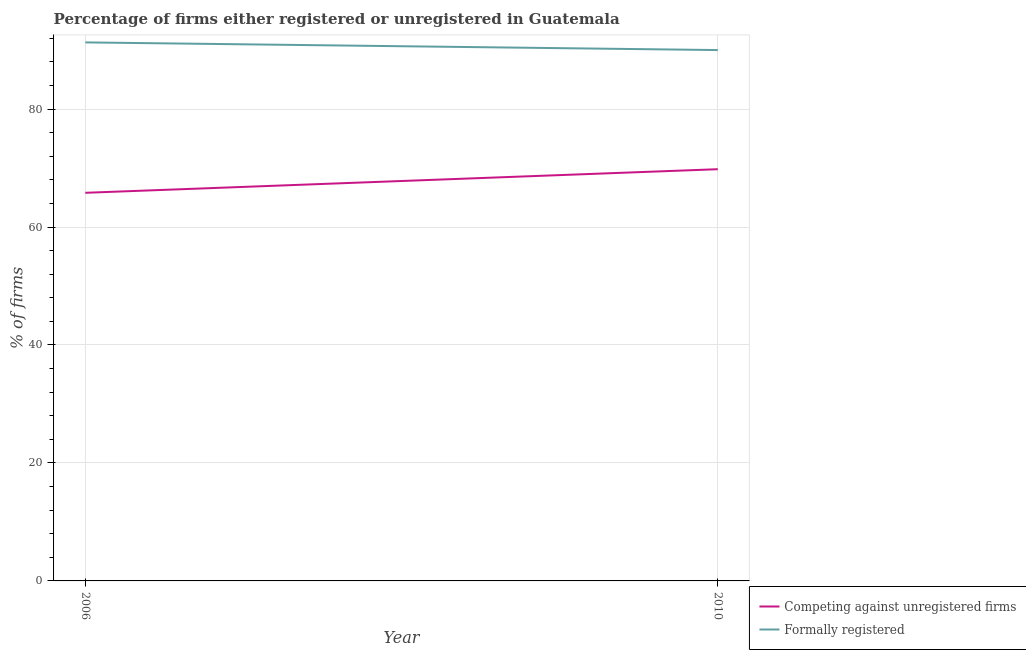How many different coloured lines are there?
Your response must be concise. 2. Is the number of lines equal to the number of legend labels?
Your answer should be very brief. Yes. Across all years, what is the maximum percentage of formally registered firms?
Make the answer very short. 91.3. Across all years, what is the minimum percentage of registered firms?
Give a very brief answer. 65.8. In which year was the percentage of formally registered firms minimum?
Your answer should be compact. 2010. What is the total percentage of registered firms in the graph?
Provide a short and direct response. 135.6. What is the average percentage of registered firms per year?
Offer a terse response. 67.8. In the year 2010, what is the difference between the percentage of formally registered firms and percentage of registered firms?
Your answer should be compact. 20.2. In how many years, is the percentage of registered firms greater than 56 %?
Ensure brevity in your answer.  2. What is the ratio of the percentage of registered firms in 2006 to that in 2010?
Keep it short and to the point. 0.94. Is the percentage of registered firms in 2006 less than that in 2010?
Your answer should be compact. Yes. Is the percentage of formally registered firms strictly greater than the percentage of registered firms over the years?
Ensure brevity in your answer.  Yes. Is the percentage of registered firms strictly less than the percentage of formally registered firms over the years?
Your response must be concise. Yes. How many lines are there?
Offer a very short reply. 2. How many years are there in the graph?
Offer a terse response. 2. Does the graph contain grids?
Your answer should be very brief. Yes. How are the legend labels stacked?
Keep it short and to the point. Vertical. What is the title of the graph?
Make the answer very short. Percentage of firms either registered or unregistered in Guatemala. What is the label or title of the Y-axis?
Your response must be concise. % of firms. What is the % of firms of Competing against unregistered firms in 2006?
Your answer should be very brief. 65.8. What is the % of firms of Formally registered in 2006?
Make the answer very short. 91.3. What is the % of firms in Competing against unregistered firms in 2010?
Offer a terse response. 69.8. What is the % of firms in Formally registered in 2010?
Your answer should be compact. 90. Across all years, what is the maximum % of firms in Competing against unregistered firms?
Keep it short and to the point. 69.8. Across all years, what is the maximum % of firms of Formally registered?
Your answer should be very brief. 91.3. Across all years, what is the minimum % of firms of Competing against unregistered firms?
Provide a short and direct response. 65.8. Across all years, what is the minimum % of firms of Formally registered?
Make the answer very short. 90. What is the total % of firms in Competing against unregistered firms in the graph?
Your answer should be very brief. 135.6. What is the total % of firms in Formally registered in the graph?
Your response must be concise. 181.3. What is the difference between the % of firms in Competing against unregistered firms in 2006 and the % of firms in Formally registered in 2010?
Give a very brief answer. -24.2. What is the average % of firms of Competing against unregistered firms per year?
Your answer should be compact. 67.8. What is the average % of firms of Formally registered per year?
Provide a short and direct response. 90.65. In the year 2006, what is the difference between the % of firms in Competing against unregistered firms and % of firms in Formally registered?
Your answer should be compact. -25.5. In the year 2010, what is the difference between the % of firms of Competing against unregistered firms and % of firms of Formally registered?
Your response must be concise. -20.2. What is the ratio of the % of firms of Competing against unregistered firms in 2006 to that in 2010?
Provide a short and direct response. 0.94. What is the ratio of the % of firms in Formally registered in 2006 to that in 2010?
Give a very brief answer. 1.01. What is the difference between the highest and the second highest % of firms in Competing against unregistered firms?
Keep it short and to the point. 4. What is the difference between the highest and the second highest % of firms of Formally registered?
Your answer should be very brief. 1.3. What is the difference between the highest and the lowest % of firms in Competing against unregistered firms?
Keep it short and to the point. 4. What is the difference between the highest and the lowest % of firms in Formally registered?
Provide a short and direct response. 1.3. 